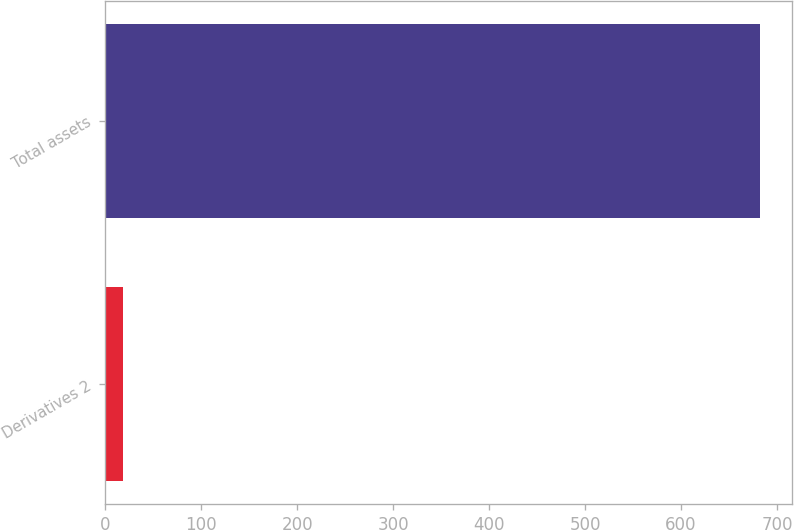<chart> <loc_0><loc_0><loc_500><loc_500><bar_chart><fcel>Derivatives 2<fcel>Total assets<nl><fcel>19<fcel>682<nl></chart> 